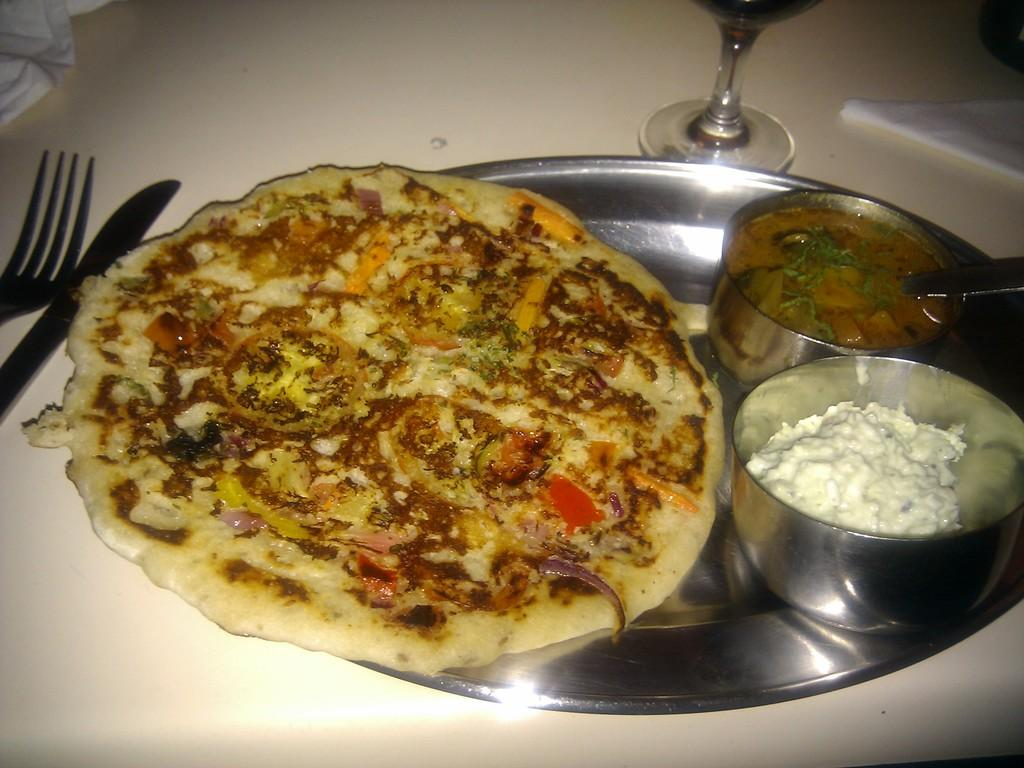What type of food is on the plate in the image? There is a roti on a plate in the image. What accompanies the roti in the image? There are two bowls with curry in the image. What type of glass is present in the image? There is a wine glass in the image. What utensils are visible in the image? There is a knife and a fork in the image. Where are all these items located? All of these items are on a table. What type of cloth is draped over the tub in the image? There is no tub or cloth present in the image; it only features a plate with roti, bowls of curry, a wine glass, a knife, and a fork on a table. 